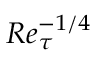Convert formula to latex. <formula><loc_0><loc_0><loc_500><loc_500>R e _ { \tau } ^ { - 1 / 4 }</formula> 